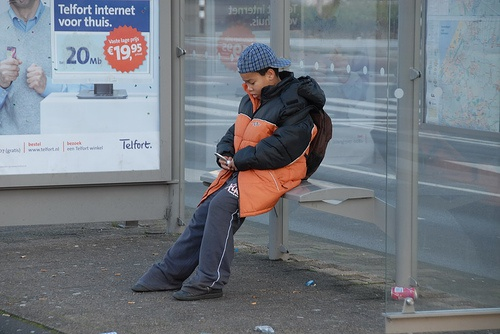Describe the objects in this image and their specific colors. I can see people in darkgray, black, gray, and salmon tones, bench in darkgray and gray tones, backpack in darkgray, black, darkblue, and gray tones, and cell phone in darkgray, gray, lightgray, and black tones in this image. 